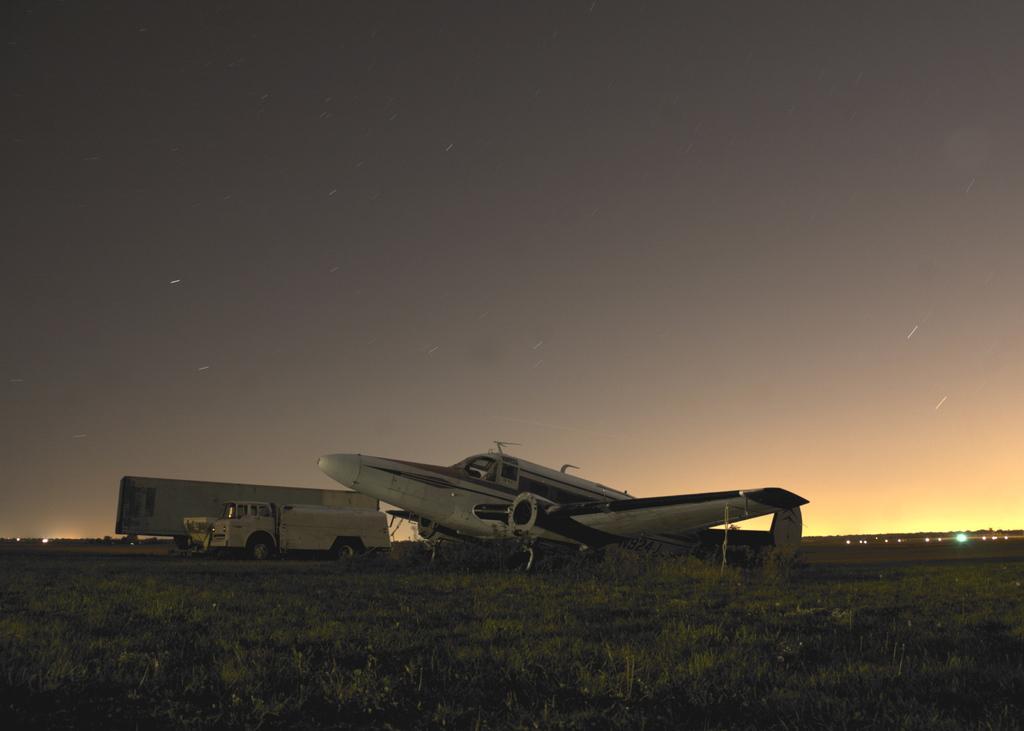Could you give a brief overview of what you see in this image? In this image I can see an aircraft and ground with grass. In background I can see vehicles over here. 